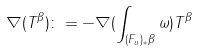Convert formula to latex. <formula><loc_0><loc_0><loc_500><loc_500>\nabla ( T ^ { \beta } ) \colon = - \nabla ( \int _ { ( F _ { u } ) _ { * } \beta } \omega ) T ^ { \beta }</formula> 